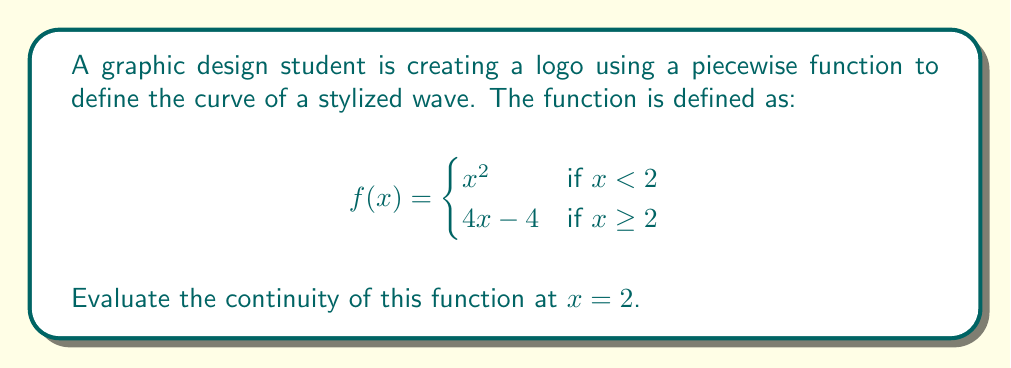Solve this math problem. To evaluate the continuity of a piecewise function at a given point, we need to check three conditions:

1. The function is defined at that point.
2. The limit of the function exists as we approach the point from both sides.
3. The limit equals the function value at that point.

Let's check these conditions for $x = 2$:

1. The function is defined at $x = 2$:
   $f(2) = 4(2) - 4 = 8 - 4 = 4$

2. Let's check the limits from both sides:

   Left-hand limit:
   $$\lim_{x \to 2^-} f(x) = \lim_{x \to 2^-} x^2 = 2^2 = 4$$

   Right-hand limit:
   $$\lim_{x \to 2^+} f(x) = \lim_{x \to 2^+} (4x - 4) = 4(2) - 4 = 4$$

   Both limits exist and are equal: $\lim_{x \to 2^-} f(x) = \lim_{x \to 2^+} f(x) = 4$

3. The common limit equals the function value at $x = 2$:
   $$\lim_{x \to 2} f(x) = f(2) = 4$$

Since all three conditions are satisfied, the function is continuous at $x = 2$.
Answer: The piecewise function is continuous at $x = 2$. 